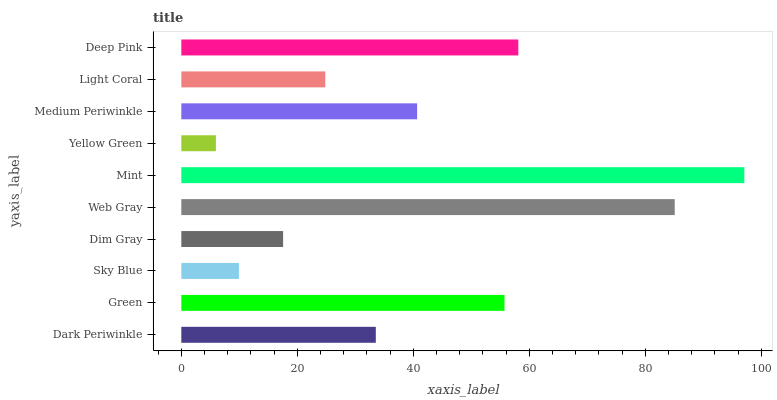Is Yellow Green the minimum?
Answer yes or no. Yes. Is Mint the maximum?
Answer yes or no. Yes. Is Green the minimum?
Answer yes or no. No. Is Green the maximum?
Answer yes or no. No. Is Green greater than Dark Periwinkle?
Answer yes or no. Yes. Is Dark Periwinkle less than Green?
Answer yes or no. Yes. Is Dark Periwinkle greater than Green?
Answer yes or no. No. Is Green less than Dark Periwinkle?
Answer yes or no. No. Is Medium Periwinkle the high median?
Answer yes or no. Yes. Is Dark Periwinkle the low median?
Answer yes or no. Yes. Is Yellow Green the high median?
Answer yes or no. No. Is Mint the low median?
Answer yes or no. No. 